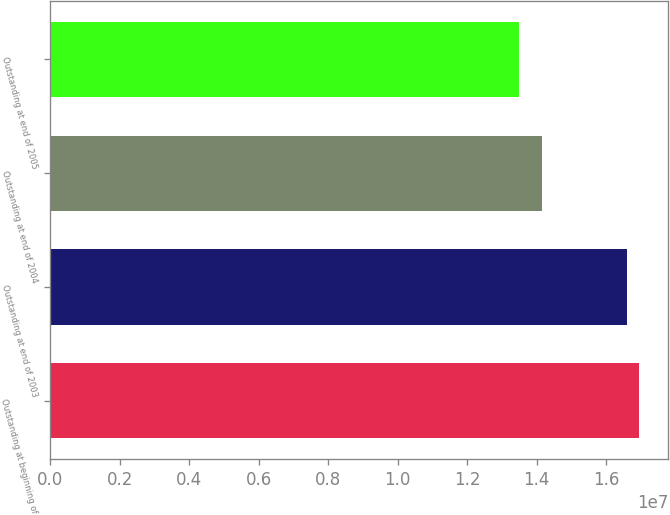Convert chart. <chart><loc_0><loc_0><loc_500><loc_500><bar_chart><fcel>Outstanding at beginning of<fcel>Outstanding at end of 2003<fcel>Outstanding at end of 2004<fcel>Outstanding at end of 2005<nl><fcel>1.6935e+07<fcel>1.6608e+07<fcel>1.41619e+07<fcel>1.34895e+07<nl></chart> 